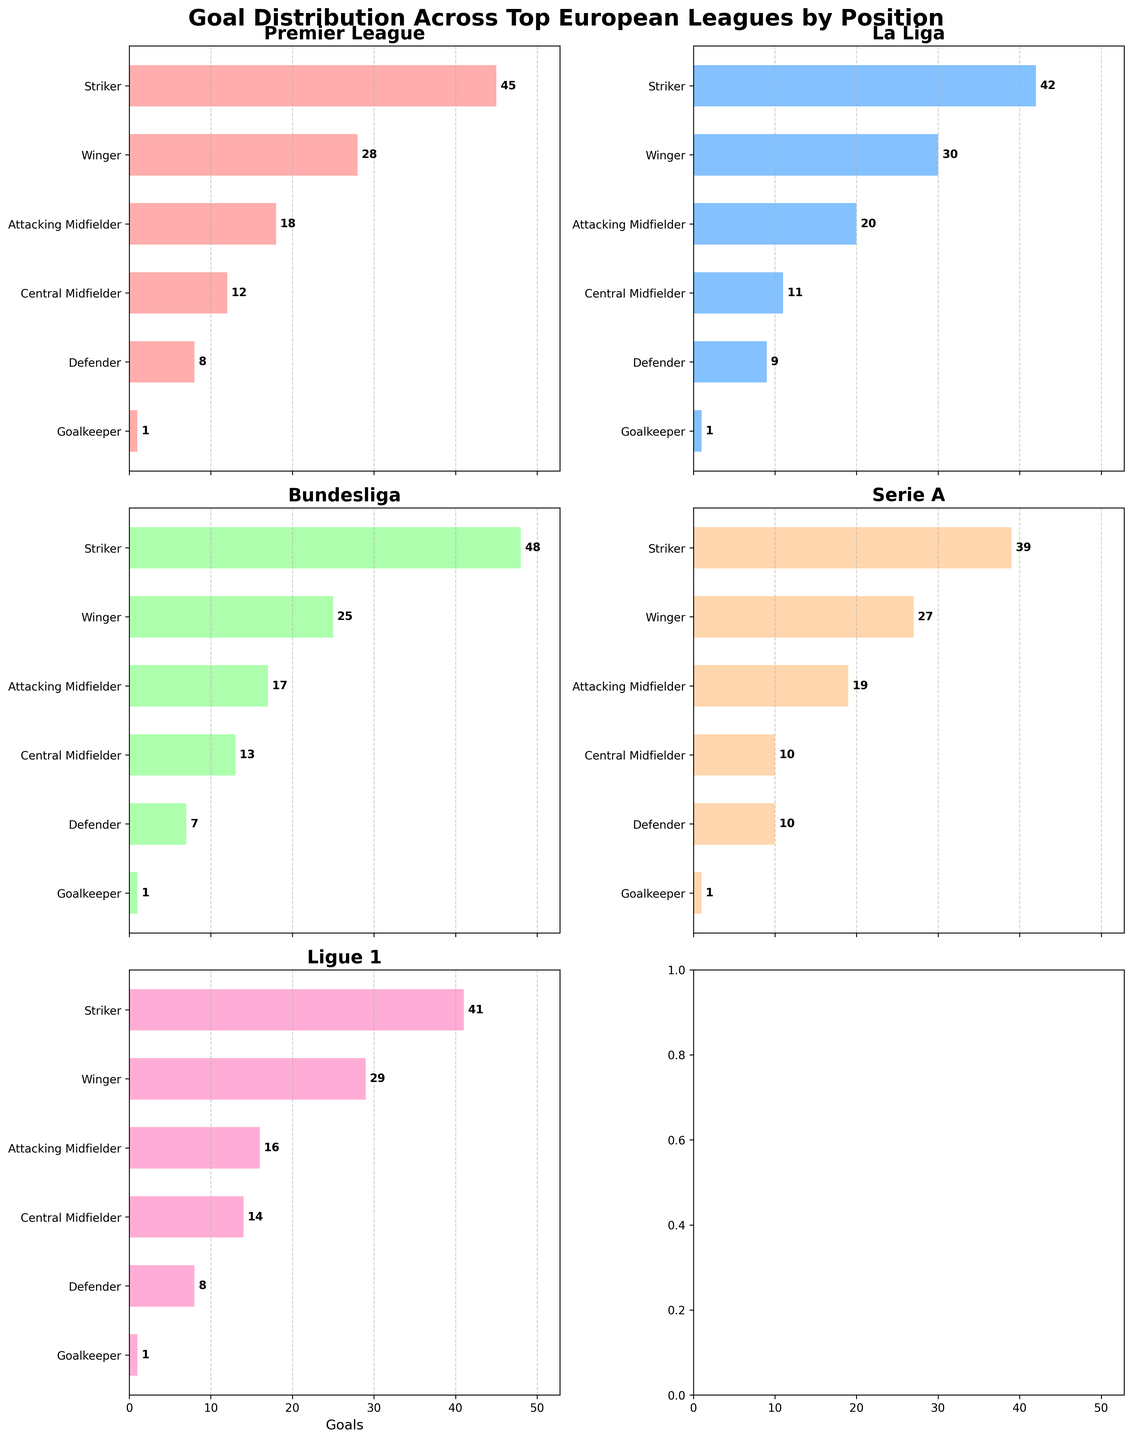What title is displayed at the top of the figure? The title of the figure is prominently placed at the top to give an overview of what the figure represents. In this case, it is "Goal Distribution Across Top European Leagues by Position."
Answer: Goal Distribution Across Top European Leagues by Position How many leagues are shown in the figure? Each subplot represents one league. Since we have subplots arranged in 3 rows and 2 columns, the total number of leagues shown is 5, as represented by the Premier League, La Liga, Bundesliga, Serie A, and Ligue 1.
Answer: 5 Which position scored the highest number of goals in the Bundesliga? To determine this, we need to look at the subplot titled "Bundesliga". We see that the "Striker" position has the longest bar, meaning it's the highest.
Answer: Striker What's the sum of goals scored by Central Midfielders in the Premier League and Serie A? Find the values for Central Midfielders in both leagues: Premier League (12) and Serie A (10). Sum them up: 12 + 10 = 22.
Answer: 22 Which league has the lowest number of goals scored by Defenders? By looking at the length of the bars for "Defender" in each subplot, we notice the Bundesliga has the shortest bar indicating 7 goals.
Answer: Bundesliga By how many goals do Wingers outscore Attacking Midfielders in La Liga? In the La Liga subplot, Wingers scored 30 goals and Attacking Midfielders scored 20 goals. The difference is 30 - 20 = 10.
Answer: 10 Compare the total goals scored by Goalkeepers across all leagues. Are they equal in each league? Check each subplot for the goals scored by Goalkeepers. Each has a value of 1 goal indicating uniformity across all leagues.
Answer: Yes Which position in Serie A has the second-highest goal count, and what is that count? In the Serie A subplot, the second-longest bar (after Striker) is for Wingers, which shows 27 goals.
Answer: Winger, 27 What is the average number of goals scored by Central Midfielders across all leagues? Add up the goals for Central Midfielders in all leagues: 12 (Premier League) + 11 (La Liga) + 13 (Bundesliga) + 10 (Serie A) + 14 (Ligue 1). There are 5 leagues, so divide the sum by 5: (12 + 11 + 13 + 10 + 14) = 60, and 60 / 5 = 12.
Answer: 12 Which position is uniformly the lowest scoring across all leagues? By scanning the subplots, it's clear the "Goalkeeper" position consistently shows the lowest number of goals: 1 in each league.
Answer: Goalkeeper 